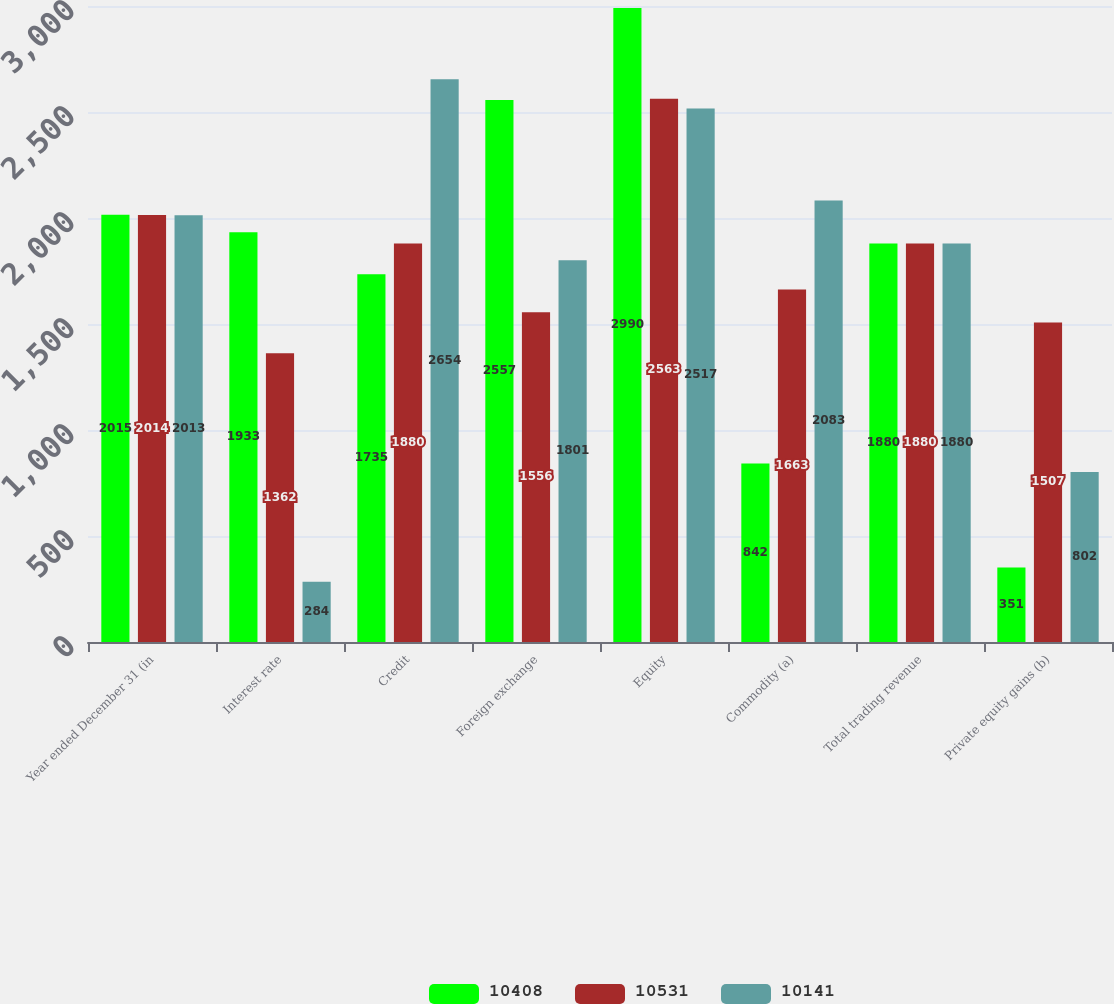<chart> <loc_0><loc_0><loc_500><loc_500><stacked_bar_chart><ecel><fcel>Year ended December 31 (in<fcel>Interest rate<fcel>Credit<fcel>Foreign exchange<fcel>Equity<fcel>Commodity (a)<fcel>Total trading revenue<fcel>Private equity gains (b)<nl><fcel>10408<fcel>2015<fcel>1933<fcel>1735<fcel>2557<fcel>2990<fcel>842<fcel>1880<fcel>351<nl><fcel>10531<fcel>2014<fcel>1362<fcel>1880<fcel>1556<fcel>2563<fcel>1663<fcel>1880<fcel>1507<nl><fcel>10141<fcel>2013<fcel>284<fcel>2654<fcel>1801<fcel>2517<fcel>2083<fcel>1880<fcel>802<nl></chart> 